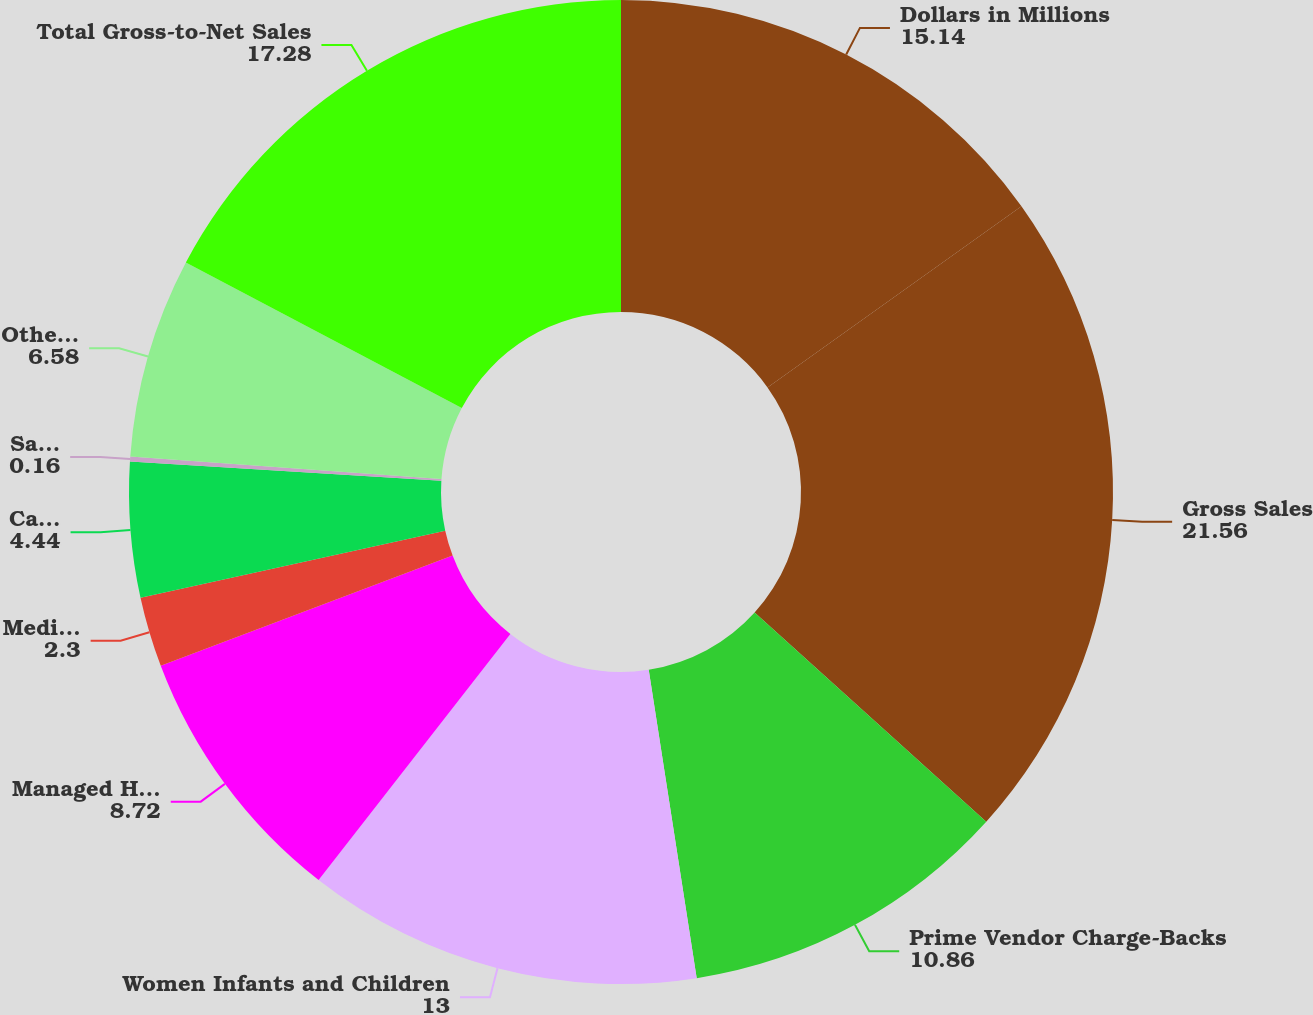Convert chart. <chart><loc_0><loc_0><loc_500><loc_500><pie_chart><fcel>Dollars in Millions<fcel>Gross Sales<fcel>Prime Vendor Charge-Backs<fcel>Women Infants and Children<fcel>Managed Health Care Rebates<fcel>Medicaid Rebates<fcel>Cash Discounts<fcel>Sales Returns<fcel>Other Adjustments<fcel>Total Gross-to-Net Sales<nl><fcel>15.14%<fcel>21.56%<fcel>10.86%<fcel>13.0%<fcel>8.72%<fcel>2.3%<fcel>4.44%<fcel>0.16%<fcel>6.58%<fcel>17.28%<nl></chart> 